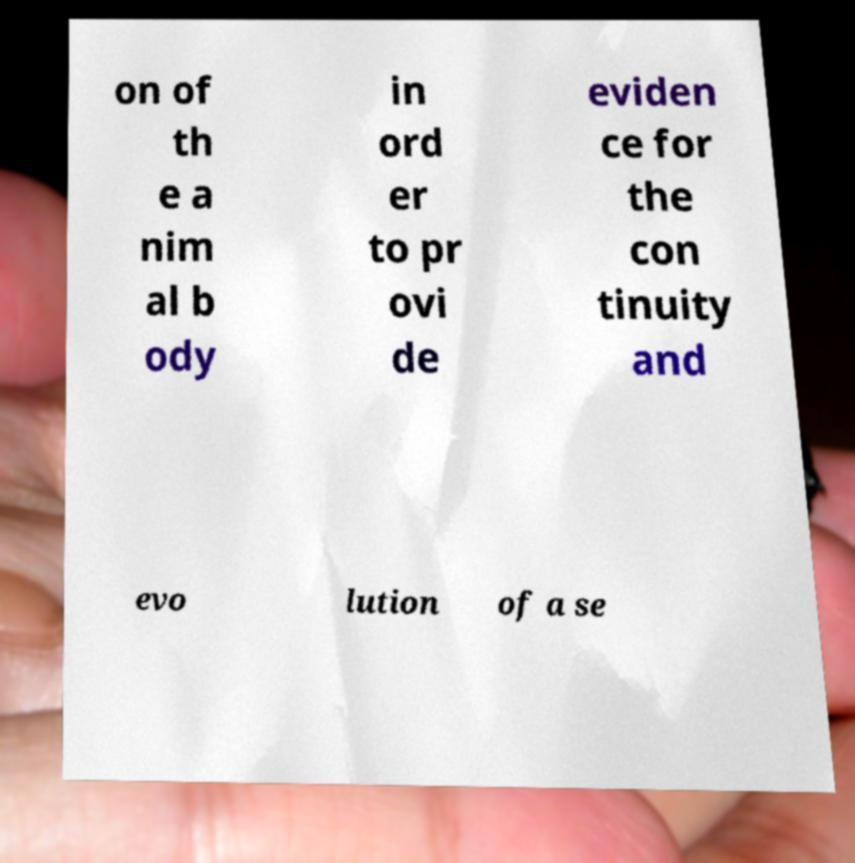Please identify and transcribe the text found in this image. on of th e a nim al b ody in ord er to pr ovi de eviden ce for the con tinuity and evo lution of a se 